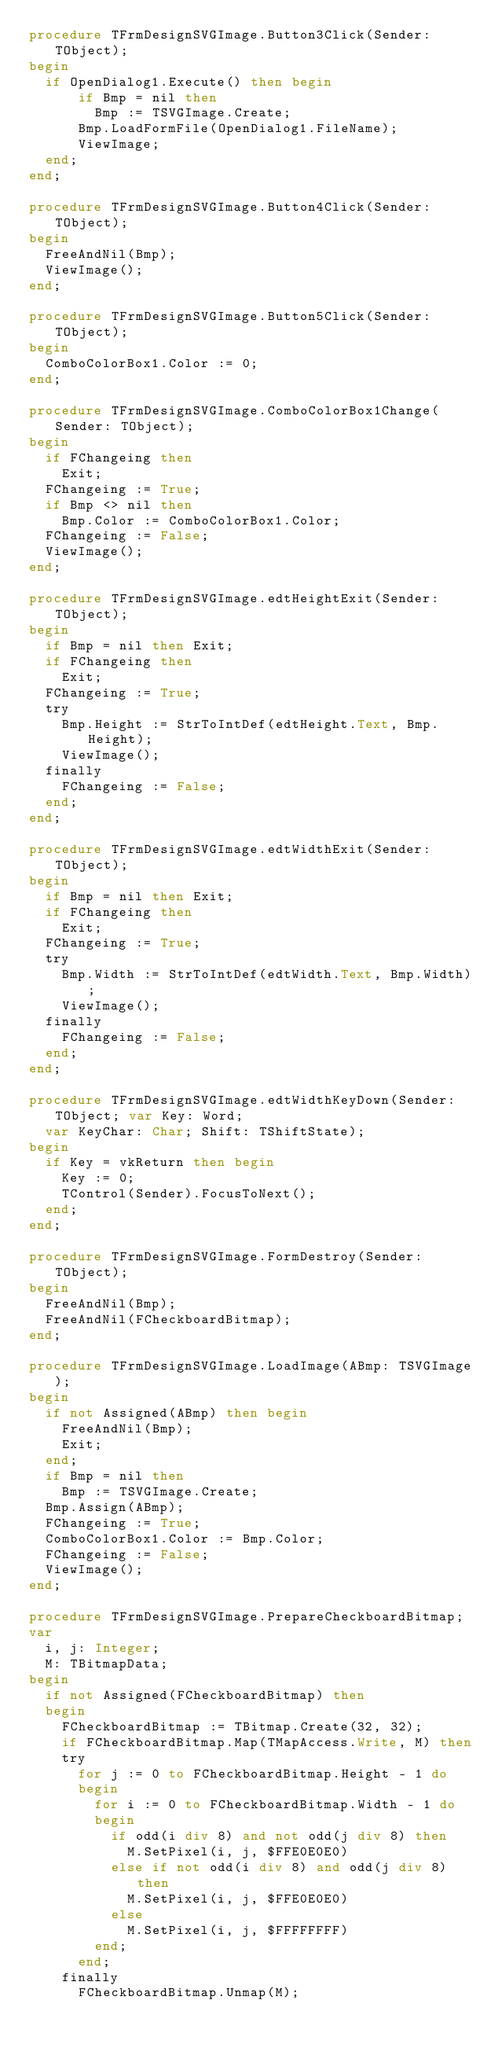Convert code to text. <code><loc_0><loc_0><loc_500><loc_500><_Pascal_>procedure TFrmDesignSVGImage.Button3Click(Sender: TObject);
begin
  if OpenDialog1.Execute() then begin
      if Bmp = nil then
        Bmp := TSVGImage.Create;
      Bmp.LoadFormFile(OpenDialog1.FileName);
      ViewImage;
  end;
end;

procedure TFrmDesignSVGImage.Button4Click(Sender: TObject);
begin
  FreeAndNil(Bmp);
  ViewImage();
end;

procedure TFrmDesignSVGImage.Button5Click(Sender: TObject);
begin
  ComboColorBox1.Color := 0;
end;

procedure TFrmDesignSVGImage.ComboColorBox1Change(Sender: TObject);
begin
  if FChangeing then
    Exit;
  FChangeing := True;
  if Bmp <> nil then
    Bmp.Color := ComboColorBox1.Color;
  FChangeing := False;
  ViewImage();
end;

procedure TFrmDesignSVGImage.edtHeightExit(Sender: TObject);
begin
  if Bmp = nil then Exit;
  if FChangeing then
    Exit;
  FChangeing := True;
  try
    Bmp.Height := StrToIntDef(edtHeight.Text, Bmp.Height);
    ViewImage();
  finally
    FChangeing := False;
  end;
end;

procedure TFrmDesignSVGImage.edtWidthExit(Sender: TObject);
begin
  if Bmp = nil then Exit;
  if FChangeing then
    Exit;
  FChangeing := True;
  try
    Bmp.Width := StrToIntDef(edtWidth.Text, Bmp.Width);
    ViewImage();
  finally
    FChangeing := False;
  end;
end;

procedure TFrmDesignSVGImage.edtWidthKeyDown(Sender: TObject; var Key: Word;
  var KeyChar: Char; Shift: TShiftState);
begin
  if Key = vkReturn then begin
    Key := 0;
    TControl(Sender).FocusToNext();
  end;
end;

procedure TFrmDesignSVGImage.FormDestroy(Sender: TObject);
begin
  FreeAndNil(Bmp);
  FreeAndNil(FCheckboardBitmap);
end;

procedure TFrmDesignSVGImage.LoadImage(ABmp: TSVGImage);
begin
  if not Assigned(ABmp) then begin
    FreeAndNil(Bmp);
    Exit;
  end;
  if Bmp = nil then
    Bmp := TSVGImage.Create;
  Bmp.Assign(ABmp);
  FChangeing := True;
  ComboColorBox1.Color := Bmp.Color;
  FChangeing := False;
  ViewImage();
end;

procedure TFrmDesignSVGImage.PrepareCheckboardBitmap;
var
  i, j: Integer;
  M: TBitmapData;
begin
  if not Assigned(FCheckboardBitmap) then
  begin
    FCheckboardBitmap := TBitmap.Create(32, 32);
    if FCheckboardBitmap.Map(TMapAccess.Write, M) then
    try
      for j := 0 to FCheckboardBitmap.Height - 1 do
      begin
        for i := 0 to FCheckboardBitmap.Width - 1 do
        begin
          if odd(i div 8) and not odd(j div 8) then
            M.SetPixel(i, j, $FFE0E0E0)
          else if not odd(i div 8) and odd(j div 8) then
            M.SetPixel(i, j, $FFE0E0E0)
          else
            M.SetPixel(i, j, $FFFFFFFF)
        end;
      end;
    finally
      FCheckboardBitmap.Unmap(M);</code> 